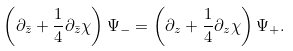Convert formula to latex. <formula><loc_0><loc_0><loc_500><loc_500>\left ( \partial _ { \bar { z } } + \frac { 1 } { 4 } \partial _ { \bar { z } } \chi \right ) \Psi _ { - } = \left ( \partial _ { z } + \frac { 1 } { 4 } \partial _ { z } \chi \right ) \Psi _ { + } .</formula> 